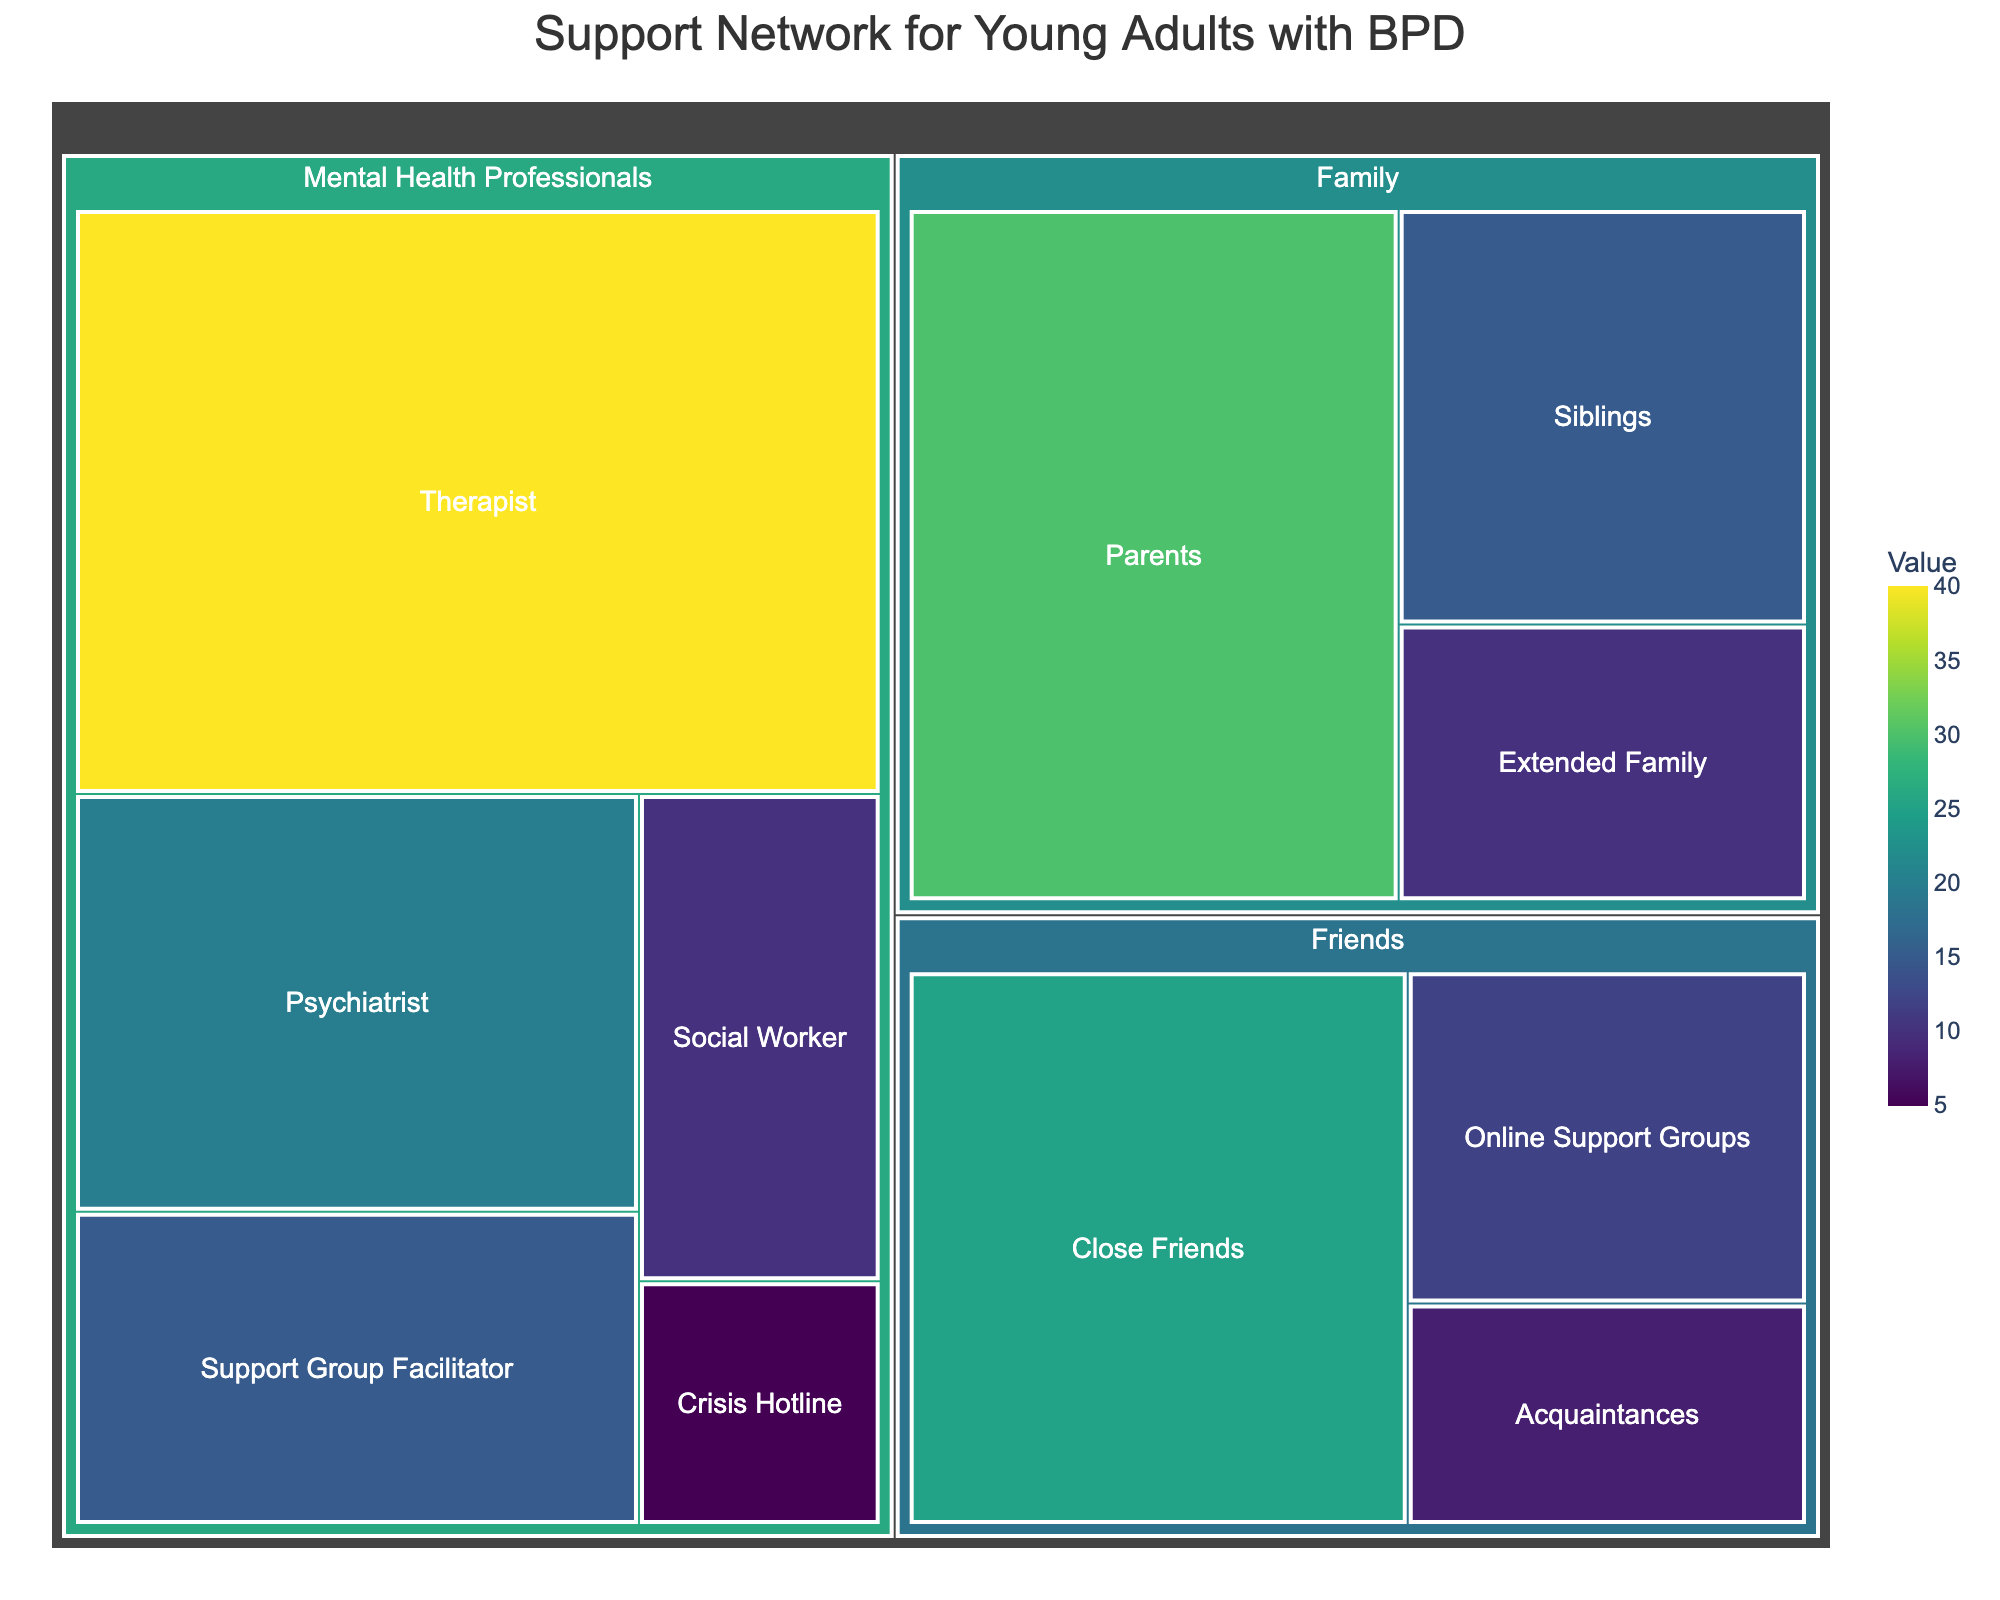What is the title of the treemap figure? The title is usually placed at the top of the figure. You can see it in bold and larger font compared to other text. In this case, the title focuses on the support network for individuals with BPD.
Answer: Support Network for Young Adults with BPD Which category has the highest total value? To find the category with the highest total value, sum up all the values within each category. Here, Family sums to 55, Friends sum to 45, and Mental Health Professionals sum to 90.
Answer: Mental Health Professionals What is the combined value of Therapists and Psychiatrists in the figure? To find the combined value, add the individual values of Therapists (40) and Psychiatrists (20).
Answer: 60 Which subcategory has the smallest value, and what is that value? Look through all the subcategories and identify the one with the smallest value number. Crisis Hotline under Mental Health Professionals has the value 5.
Answer: Crisis Hotline, 5 How much larger is the value of Parents compared to Extended Family? To find how much larger Parents is compared to Extended Family, subtract the value of Extended Family (10) from the value of Parents (30).
Answer: 20 Which family member has the highest representation in the support network? Within the Family category, compare the values of Parents, Siblings, and Extended Family. Parents have the highest value.
Answer: Parents What is the total value of all the Mental Health Professionals subcategories? Sum all the subcategory values under Mental Health Professionals: Therapist (40) + Psychiatrist (20) + Support Group Facilitator (15) + Social Worker (10) + Crisis Hotline (5). The sum is 40 + 20 + 15 + 10 + 5.
Answer: 90 Are there more Friends or Family in the support network? Sum the total values for each category. Family has a total value of 55 (30 + 15 + 10), and Friends have a total value of 45 (25 + 8 + 12). Comparatively, Family is higher.
Answer: Family What are the three subcategories under Friends and their values? Identify the subcategories under the Friends category. They are Close Friends (25), Acquaintances (8), and Online Support Groups (12).
Answer: Close Friends: 25, Acquaintances: 8, Online Support Groups: 12 What percentage of the support network is composed of Therapists? To find this percentage, divide the value of Therapists (40) by the total value of all subcategories (55+45+90=190) and multiply by 100. The calculation is (40/190) * 100.
Answer: ~21.05% 